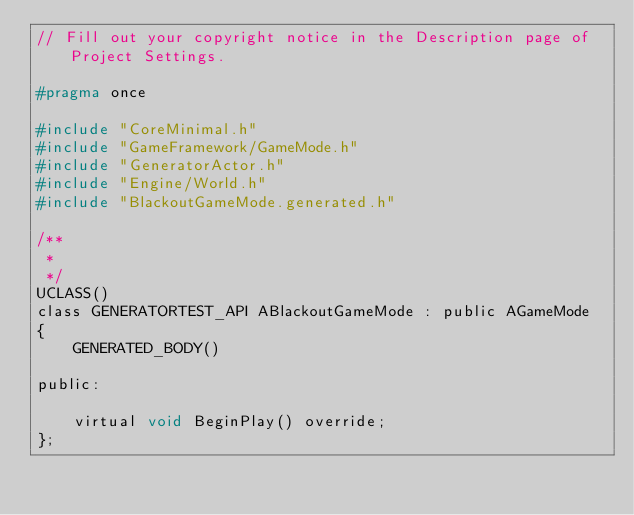<code> <loc_0><loc_0><loc_500><loc_500><_C_>// Fill out your copyright notice in the Description page of Project Settings.

#pragma once

#include "CoreMinimal.h"
#include "GameFramework/GameMode.h"
#include "GeneratorActor.h"
#include "Engine/World.h"
#include "BlackoutGameMode.generated.h"

/**
 * 
 */
UCLASS()
class GENERATORTEST_API ABlackoutGameMode : public AGameMode
{
	GENERATED_BODY()

public:

	virtual void BeginPlay() override;
};
</code> 